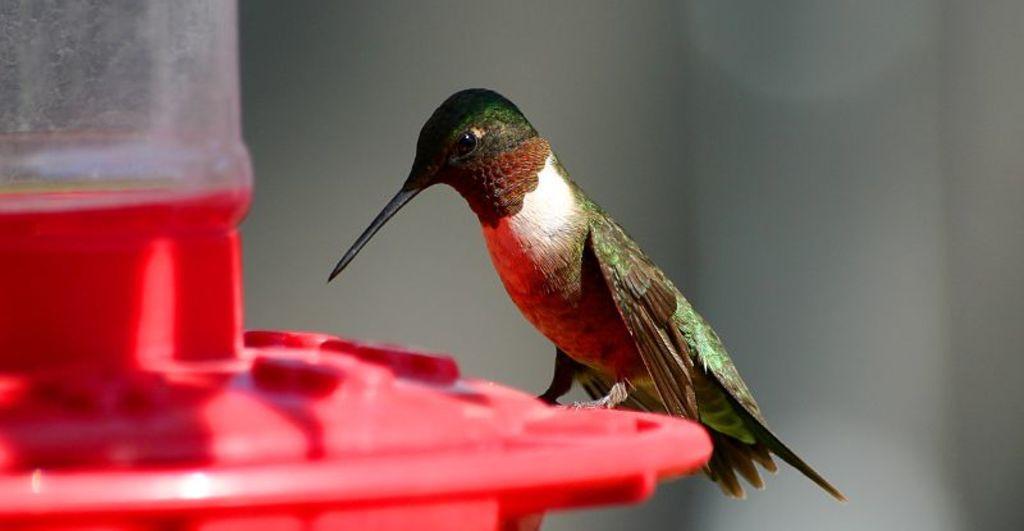In one or two sentences, can you explain what this image depicts? Here in this picture we can see a bird represent on a place over there. 